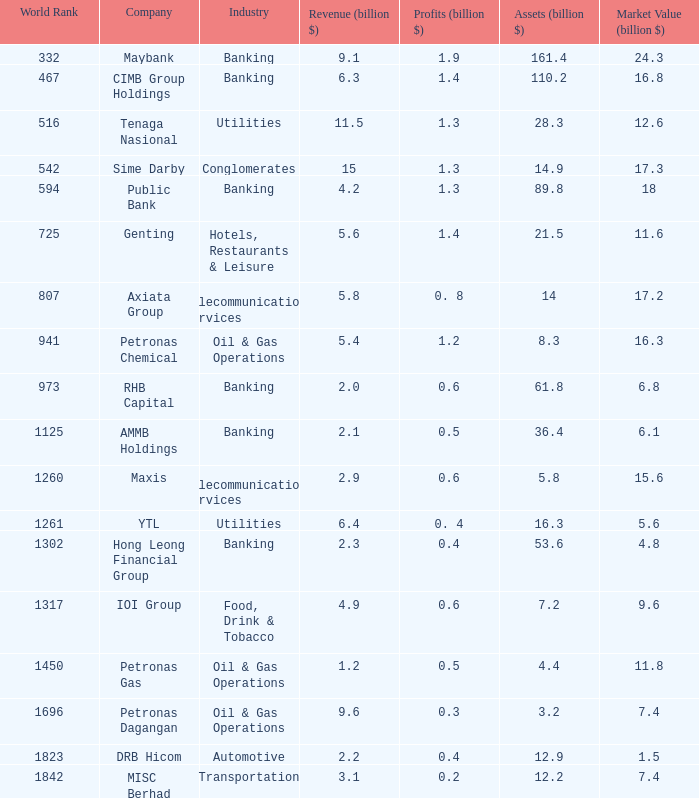Determine the returns for market value of 1 0.5. 